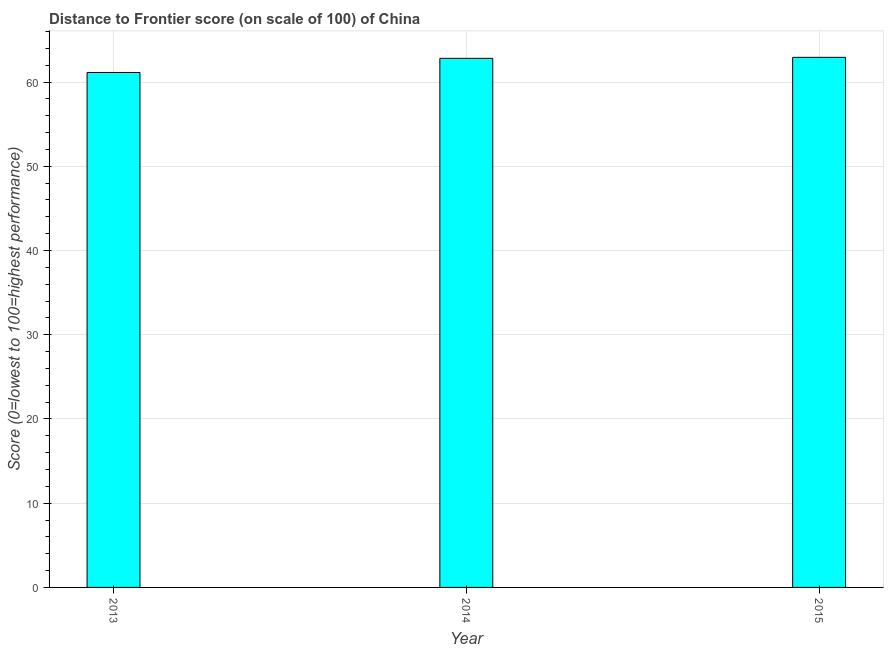Does the graph contain any zero values?
Ensure brevity in your answer.  No. Does the graph contain grids?
Provide a succinct answer. Yes. What is the title of the graph?
Your response must be concise. Distance to Frontier score (on scale of 100) of China. What is the label or title of the X-axis?
Ensure brevity in your answer.  Year. What is the label or title of the Y-axis?
Offer a terse response. Score (0=lowest to 100=highest performance). What is the distance to frontier score in 2013?
Offer a very short reply. 61.13. Across all years, what is the maximum distance to frontier score?
Make the answer very short. 62.93. Across all years, what is the minimum distance to frontier score?
Ensure brevity in your answer.  61.13. In which year was the distance to frontier score maximum?
Ensure brevity in your answer.  2015. In which year was the distance to frontier score minimum?
Your answer should be very brief. 2013. What is the sum of the distance to frontier score?
Your answer should be very brief. 186.87. What is the difference between the distance to frontier score in 2014 and 2015?
Ensure brevity in your answer.  -0.12. What is the average distance to frontier score per year?
Offer a terse response. 62.29. What is the median distance to frontier score?
Provide a succinct answer. 62.81. Is the distance to frontier score in 2014 less than that in 2015?
Your answer should be compact. Yes. What is the difference between the highest and the second highest distance to frontier score?
Offer a very short reply. 0.12. In how many years, is the distance to frontier score greater than the average distance to frontier score taken over all years?
Ensure brevity in your answer.  2. Are all the bars in the graph horizontal?
Your answer should be compact. No. How many years are there in the graph?
Keep it short and to the point. 3. Are the values on the major ticks of Y-axis written in scientific E-notation?
Give a very brief answer. No. What is the Score (0=lowest to 100=highest performance) of 2013?
Keep it short and to the point. 61.13. What is the Score (0=lowest to 100=highest performance) of 2014?
Offer a very short reply. 62.81. What is the Score (0=lowest to 100=highest performance) in 2015?
Give a very brief answer. 62.93. What is the difference between the Score (0=lowest to 100=highest performance) in 2013 and 2014?
Provide a succinct answer. -1.68. What is the difference between the Score (0=lowest to 100=highest performance) in 2014 and 2015?
Your answer should be compact. -0.12. What is the ratio of the Score (0=lowest to 100=highest performance) in 2013 to that in 2014?
Ensure brevity in your answer.  0.97. 